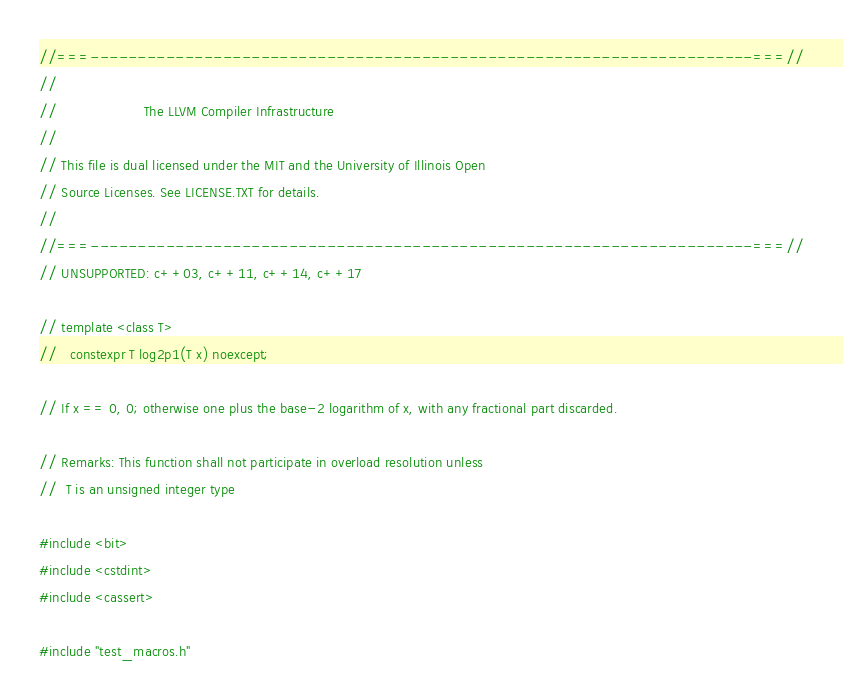<code> <loc_0><loc_0><loc_500><loc_500><_C++_>//===----------------------------------------------------------------------===//
//
//                     The LLVM Compiler Infrastructure
//
// This file is dual licensed under the MIT and the University of Illinois Open
// Source Licenses. See LICENSE.TXT for details.
//
//===----------------------------------------------------------------------===//
// UNSUPPORTED: c++03, c++11, c++14, c++17

// template <class T>
//   constexpr T log2p1(T x) noexcept;

// If x == 0, 0; otherwise one plus the base-2 logarithm of x, with any fractional part discarded.

// Remarks: This function shall not participate in overload resolution unless
//	T is an unsigned integer type

#include <bit>
#include <cstdint>
#include <cassert>

#include "test_macros.h"
</code> 